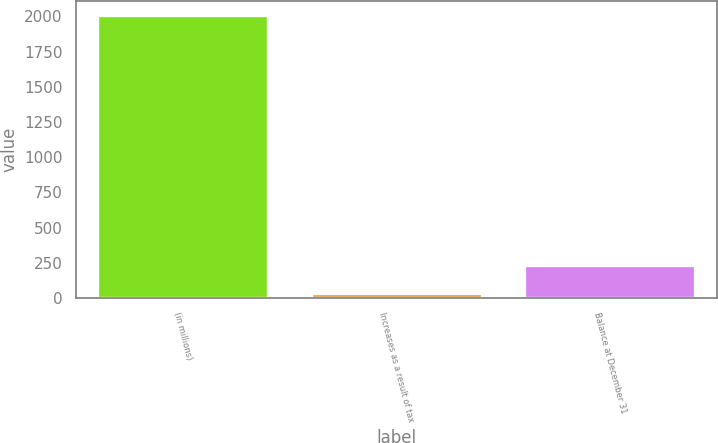Convert chart. <chart><loc_0><loc_0><loc_500><loc_500><bar_chart><fcel>(in millions)<fcel>Increases as a result of tax<fcel>Balance at December 31<nl><fcel>2012<fcel>33<fcel>230.9<nl></chart> 